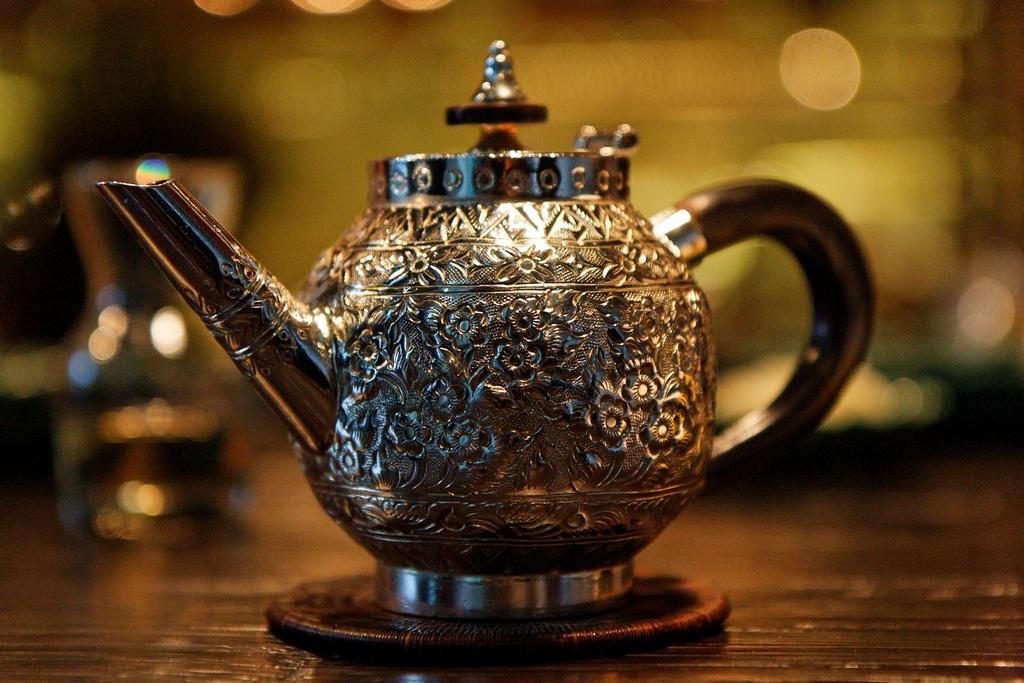Could you give a brief overview of what you see in this image? Here we can see a kettle on a platform and there is a blur background. 